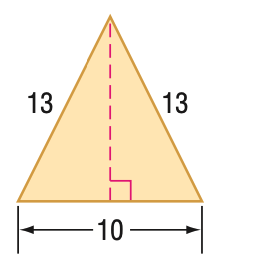Answer the mathemtical geometry problem and directly provide the correct option letter.
Question: Find the perimeter of the figure.
Choices: A: 23 B: 26 C: 36 D: 72 C 